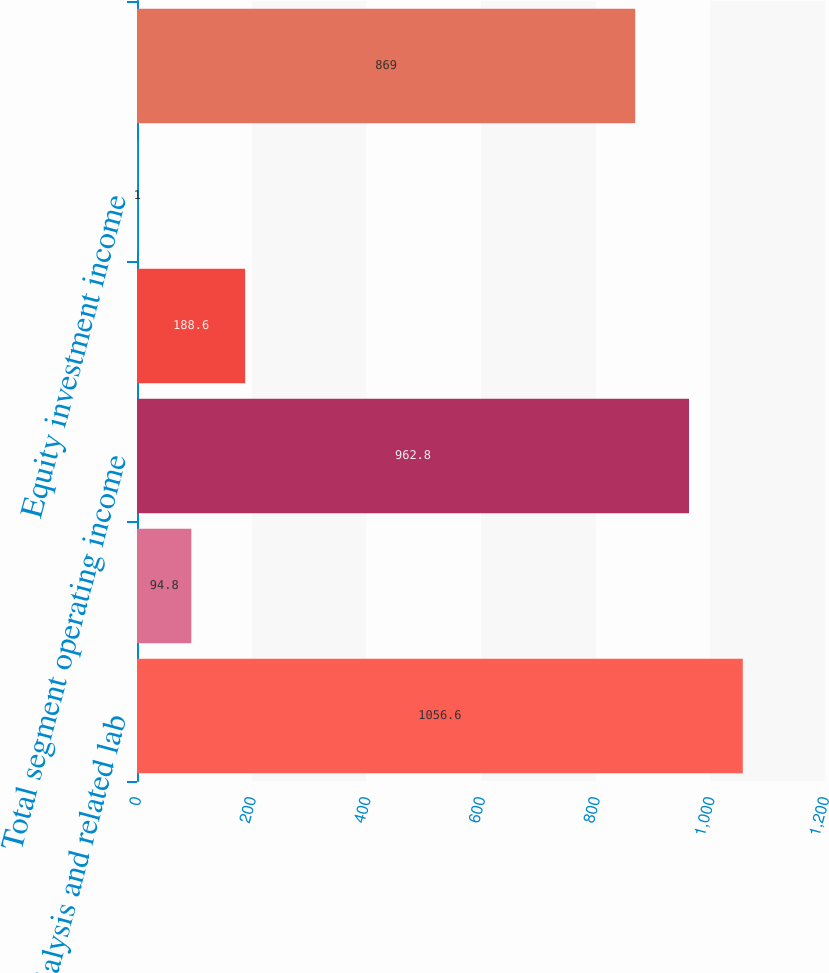Convert chart to OTSL. <chart><loc_0><loc_0><loc_500><loc_500><bar_chart><fcel>Dialysis and related lab<fcel>Other-ancillary services and<fcel>Total segment operating income<fcel>Stock-based compensation<fcel>Equity investment income<fcel>Consolidated operating income<nl><fcel>1056.6<fcel>94.8<fcel>962.8<fcel>188.6<fcel>1<fcel>869<nl></chart> 